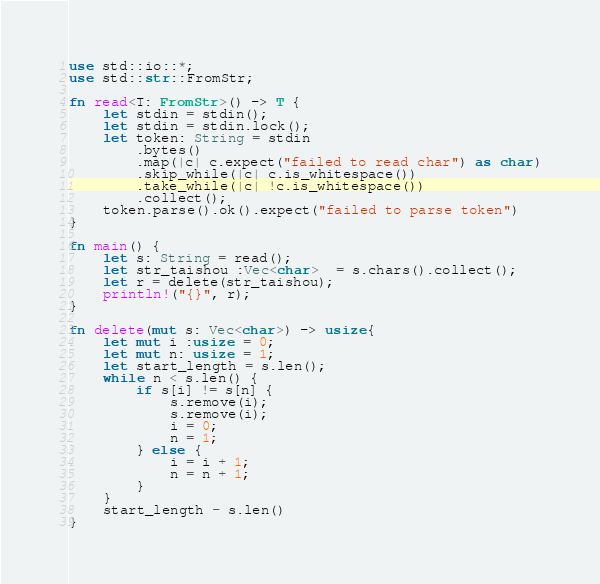Convert code to text. <code><loc_0><loc_0><loc_500><loc_500><_Rust_>use std::io::*;
use std::str::FromStr;

fn read<T: FromStr>() -> T {
    let stdin = stdin();
    let stdin = stdin.lock();
    let token: String = stdin
        .bytes()
        .map(|c| c.expect("failed to read char") as char)
        .skip_while(|c| c.is_whitespace())
        .take_while(|c| !c.is_whitespace())
        .collect();
    token.parse().ok().expect("failed to parse token")
}

fn main() {
    let s: String = read();
    let str_taishou :Vec<char>  = s.chars().collect();
    let r = delete(str_taishou);
    println!("{}", r);
}

fn delete(mut s: Vec<char>) -> usize{
    let mut i :usize = 0;
    let mut n: usize = 1;
    let start_length = s.len();
    while n < s.len() {
        if s[i] != s[n] {
            s.remove(i);
            s.remove(i);
            i = 0;
            n = 1;
        } else {
            i = i + 1;
            n = n + 1;
        }
    }
    start_length - s.len()
}

</code> 